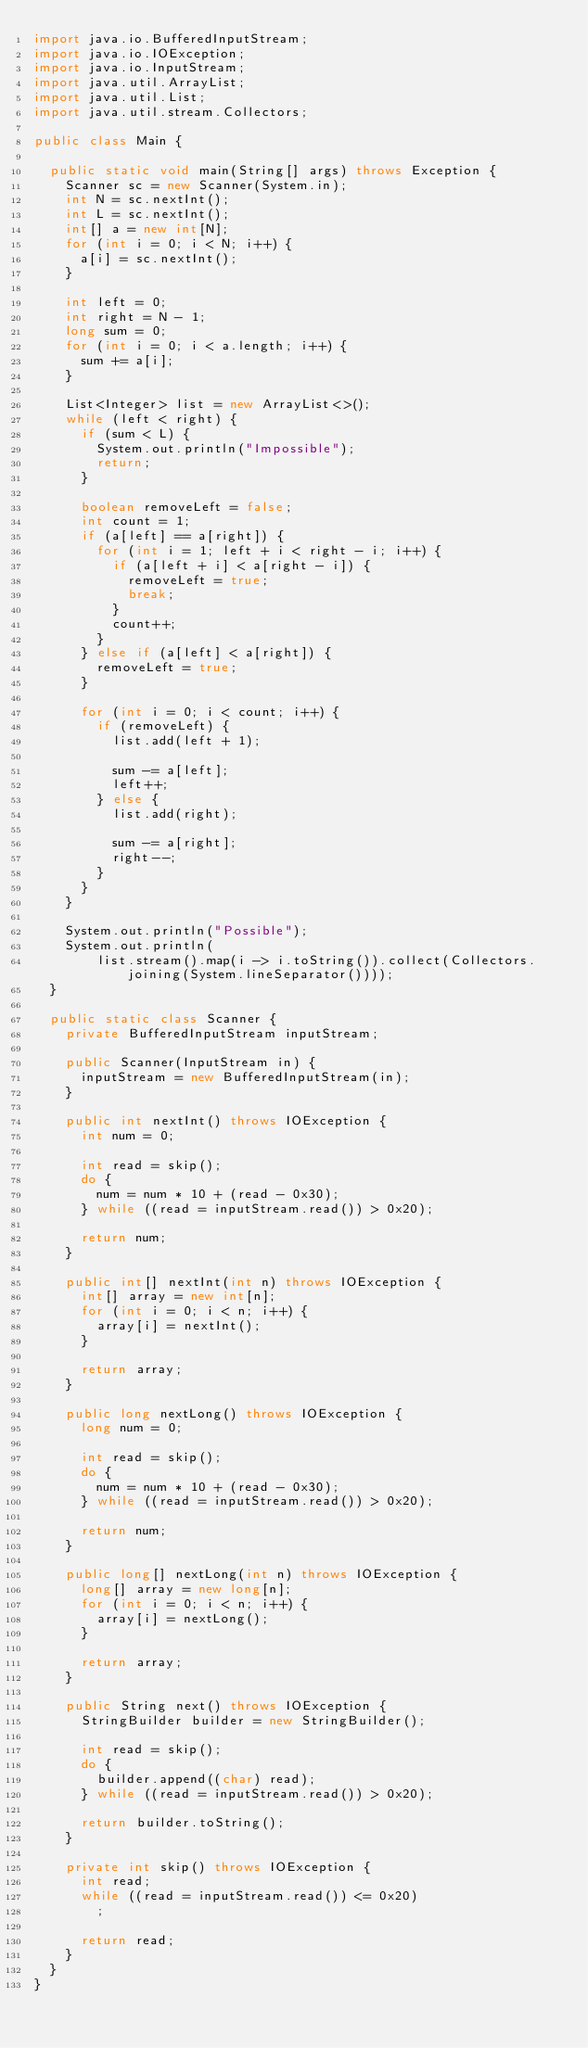Convert code to text. <code><loc_0><loc_0><loc_500><loc_500><_Java_>import java.io.BufferedInputStream;
import java.io.IOException;
import java.io.InputStream;
import java.util.ArrayList;
import java.util.List;
import java.util.stream.Collectors;

public class Main {

	public static void main(String[] args) throws Exception {
		Scanner sc = new Scanner(System.in);
		int N = sc.nextInt();
		int L = sc.nextInt();
		int[] a = new int[N];
		for (int i = 0; i < N; i++) {
			a[i] = sc.nextInt();
		}

		int left = 0;
		int right = N - 1;
		long sum = 0;
		for (int i = 0; i < a.length; i++) {
			sum += a[i];
		}

		List<Integer> list = new ArrayList<>();
		while (left < right) {
			if (sum < L) {
				System.out.println("Impossible");
				return;
			}

			boolean removeLeft = false;
			int count = 1;
			if (a[left] == a[right]) {
				for (int i = 1; left + i < right - i; i++) {
					if (a[left + i] < a[right - i]) {
						removeLeft = true;
						break;
					}
					count++;
				}
			} else if (a[left] < a[right]) {
				removeLeft = true;
			}

			for (int i = 0; i < count; i++) {
				if (removeLeft) {
					list.add(left + 1);

					sum -= a[left];
					left++;
				} else {
					list.add(right);

					sum -= a[right];
					right--;
				}
			}
		}

		System.out.println("Possible");
		System.out.println(
				list.stream().map(i -> i.toString()).collect(Collectors.joining(System.lineSeparator())));
	}

	public static class Scanner {
		private BufferedInputStream inputStream;

		public Scanner(InputStream in) {
			inputStream = new BufferedInputStream(in);
		}

		public int nextInt() throws IOException {
			int num = 0;

			int read = skip();
			do {
				num = num * 10 + (read - 0x30);
			} while ((read = inputStream.read()) > 0x20);

			return num;
		}

		public int[] nextInt(int n) throws IOException {
			int[] array = new int[n];
			for (int i = 0; i < n; i++) {
				array[i] = nextInt();
			}

			return array;
		}

		public long nextLong() throws IOException {
			long num = 0;

			int read = skip();
			do {
				num = num * 10 + (read - 0x30);
			} while ((read = inputStream.read()) > 0x20);

			return num;
		}

		public long[] nextLong(int n) throws IOException {
			long[] array = new long[n];
			for (int i = 0; i < n; i++) {
				array[i] = nextLong();
			}

			return array;
		}

		public String next() throws IOException {
			StringBuilder builder = new StringBuilder();

			int read = skip();
			do {
				builder.append((char) read);
			} while ((read = inputStream.read()) > 0x20);

			return builder.toString();
		}

		private int skip() throws IOException {
			int read;
			while ((read = inputStream.read()) <= 0x20)
				;

			return read;
		}
	}
}
</code> 